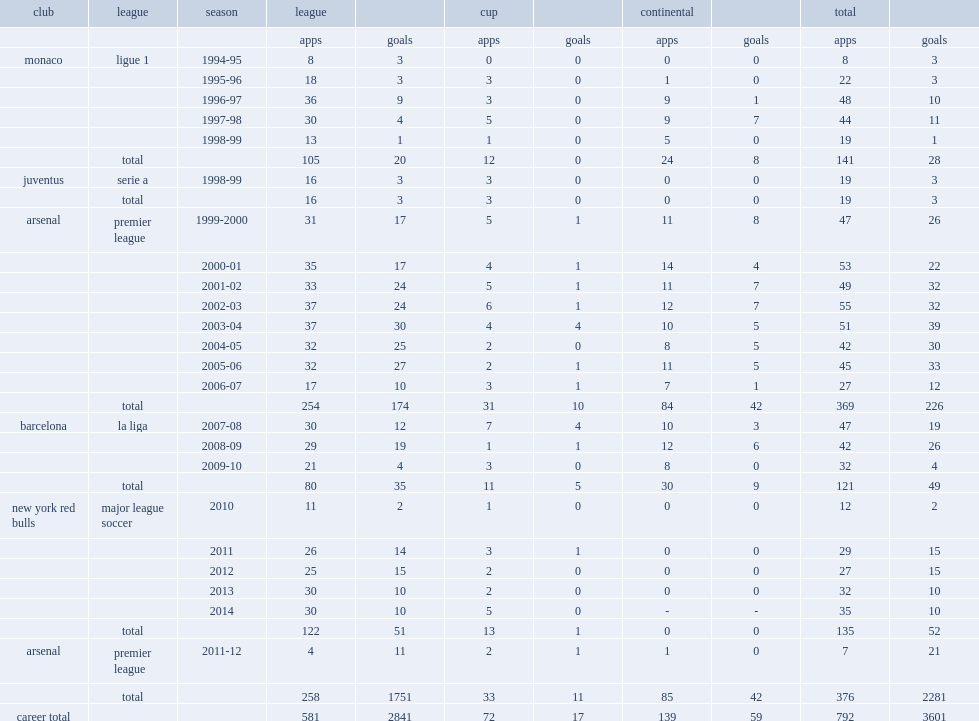In 2010, which season did henry participate with major league soccer (mls) club new york red bulls? 2010. 